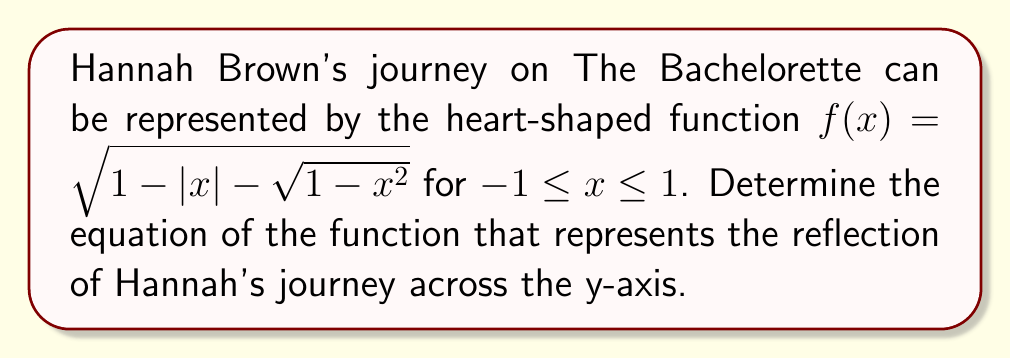Provide a solution to this math problem. To reflect a function across the y-axis, we replace every x with -x in the original function. Let's go through this step-by-step:

1. Start with the original function:
   $f(x) = \sqrt{1 - |x| - \sqrt{1-x^2}}$

2. Replace every x with -x:
   $g(x) = \sqrt{1 - |-x| - \sqrt{1-(-x)^2}}$

3. Simplify the absolute value term:
   $|-x| = |x|$, so this part doesn't change.

4. Simplify the squared term inside the square root:
   $(-x)^2 = x^2$

5. Our new function becomes:
   $g(x) = \sqrt{1 - |x| - \sqrt{1-x^2}}$

6. Notice that this is exactly the same as our original function $f(x)$.

This means that Hannah Brown's journey, when represented by this heart-shaped function, is symmetrical about the y-axis. The reflection across the y-axis results in the same function, which could symbolize the balance and consistency in Hannah's journey throughout the season.
Answer: $g(x) = \sqrt{1 - |x| - \sqrt{1-x^2}}$ 